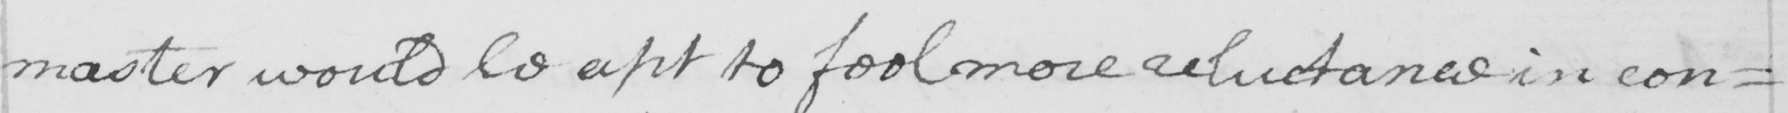Please provide the text content of this handwritten line. master would be apt to feel more reluctance in con= 